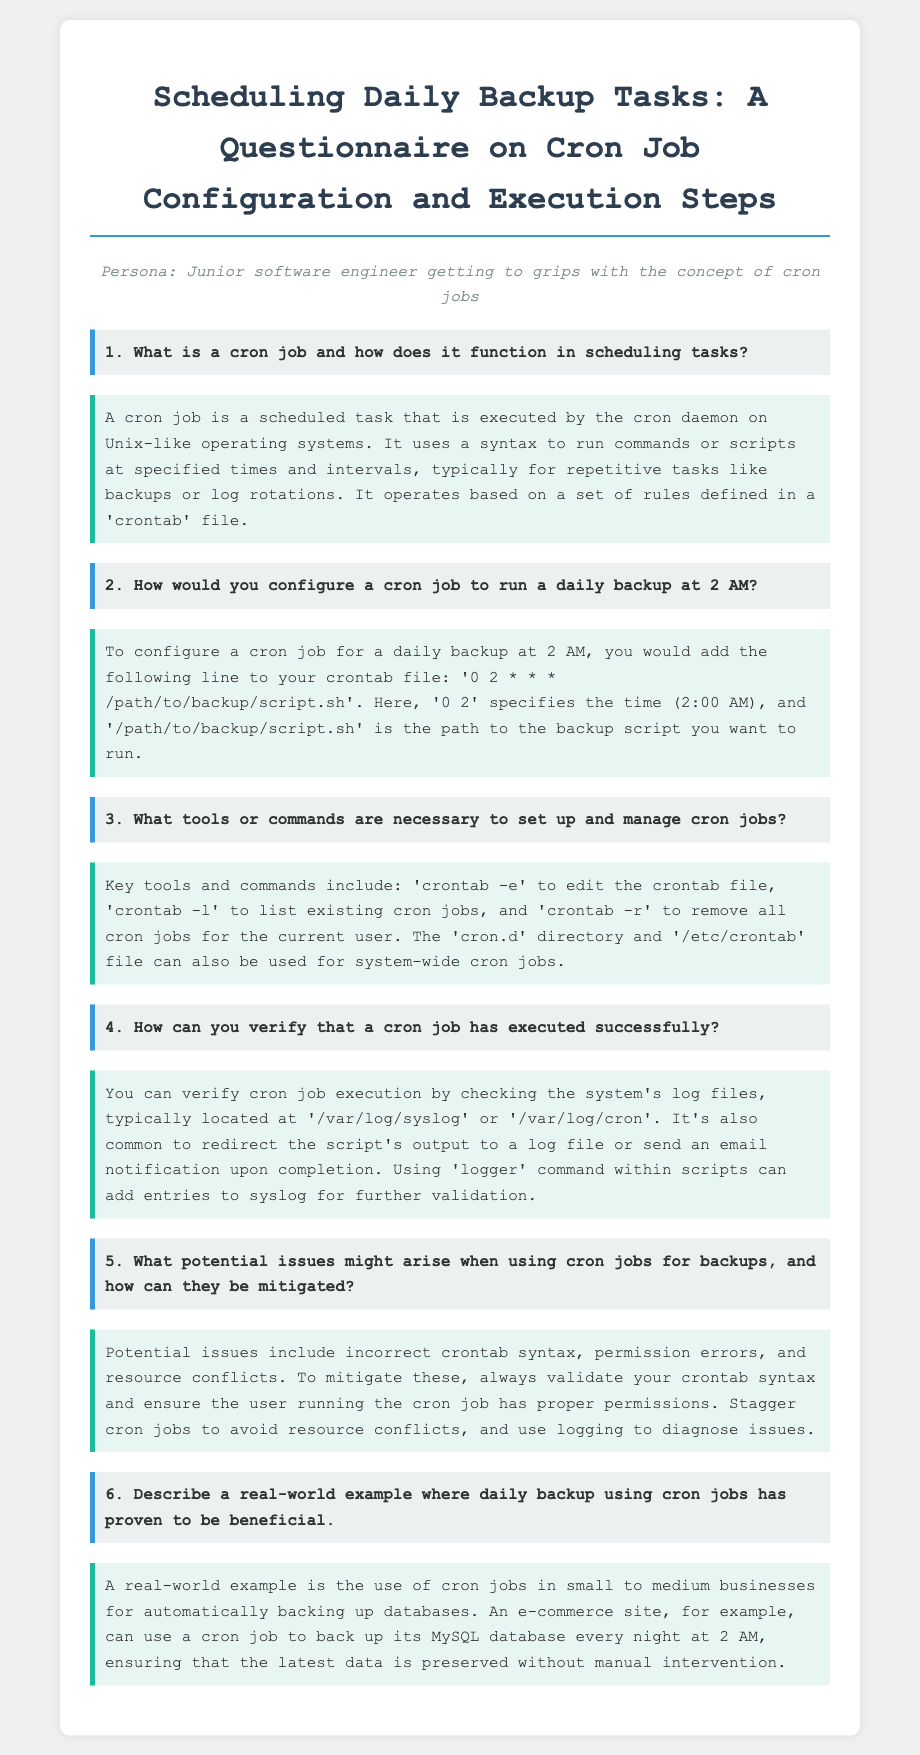What is a cron job? A cron job is a scheduled task executed by the cron daemon on Unix-like operating systems.
Answer: A scheduled task How often does the cron job run in the configuration example provided? The configuration example specifies running the cron job daily at 2 AM.
Answer: Daily What command is used to edit the crontab file? The document states that 'crontab -e' is the command used to edit the crontab file.
Answer: crontab -e Where is the common log file for cron job execution located? The document mentions that common log files are located at '/var/log/syslog' or '/var/log/cron'.
Answer: /var/log/syslog What time is the daily backup scheduled in the example? The example specifies that the daily backup is scheduled for 2 AM.
Answer: 2 AM What potential issue is highlighted regarding permissions for cron jobs? The document identifies permission errors as a potential issue.
Answer: Permission errors What is a benefit of using cron jobs for backups in e-commerce? The document states it ensures that the latest data is preserved without manual intervention.
Answer: Preserves latest data Which command helps in diagnosing cron job issues? The document mentions using logging to diagnose issues, specifically using the 'logger' command.
Answer: logger 